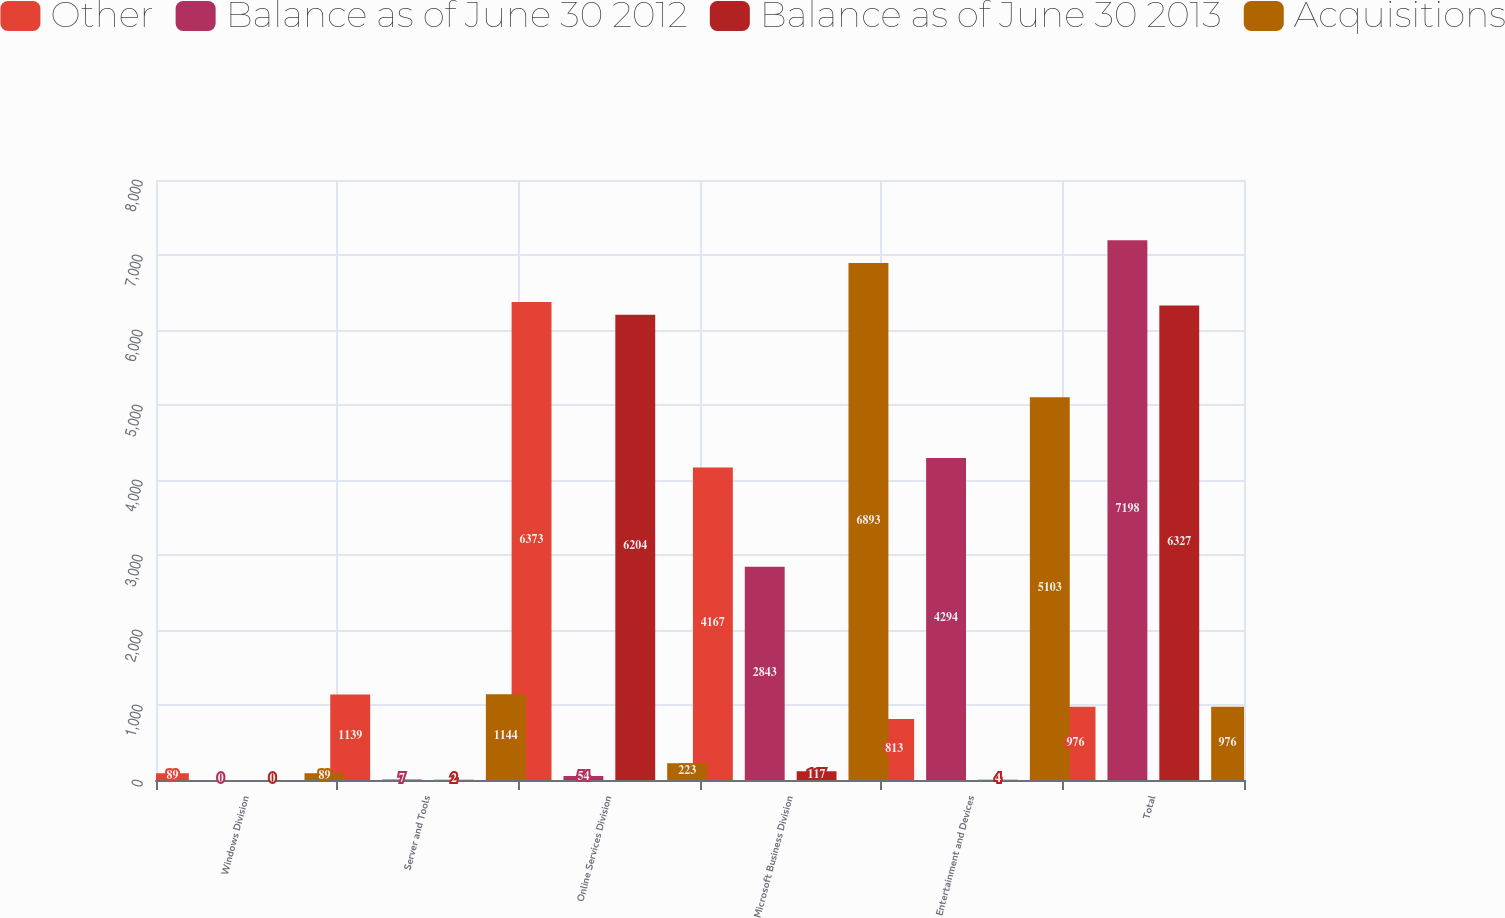Convert chart to OTSL. <chart><loc_0><loc_0><loc_500><loc_500><stacked_bar_chart><ecel><fcel>Windows Division<fcel>Server and Tools<fcel>Online Services Division<fcel>Microsoft Business Division<fcel>Entertainment and Devices<fcel>Total<nl><fcel>Other<fcel>89<fcel>1139<fcel>6373<fcel>4167<fcel>813<fcel>976<nl><fcel>Balance as of June 30 2012<fcel>0<fcel>7<fcel>54<fcel>2843<fcel>4294<fcel>7198<nl><fcel>Balance as of June 30 2013<fcel>0<fcel>2<fcel>6204<fcel>117<fcel>4<fcel>6327<nl><fcel>Acquisitions<fcel>89<fcel>1144<fcel>223<fcel>6893<fcel>5103<fcel>976<nl></chart> 